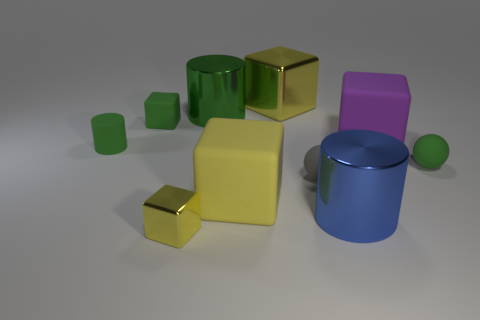There is a blue thing that is the same shape as the large green shiny thing; what is it made of?
Offer a very short reply. Metal. There is a blue shiny object; does it have the same size as the purple block behind the yellow rubber cube?
Make the answer very short. Yes. Is there another rubber object of the same size as the blue object?
Provide a short and direct response. Yes. What number of other objects are the same material as the purple thing?
Give a very brief answer. 5. What color is the cylinder that is both to the right of the green rubber cube and in front of the green metal object?
Provide a succinct answer. Blue. Is the cylinder that is behind the large purple cube made of the same material as the ball right of the tiny gray sphere?
Give a very brief answer. No. Do the metallic cylinder to the right of the gray ball and the small yellow metallic object have the same size?
Your response must be concise. No. There is a small rubber cube; is it the same color as the thing that is behind the green shiny cylinder?
Your response must be concise. No. What is the shape of the rubber thing that is the same color as the tiny metallic thing?
Your answer should be compact. Cube. What is the shape of the green metal thing?
Your response must be concise. Cylinder. 